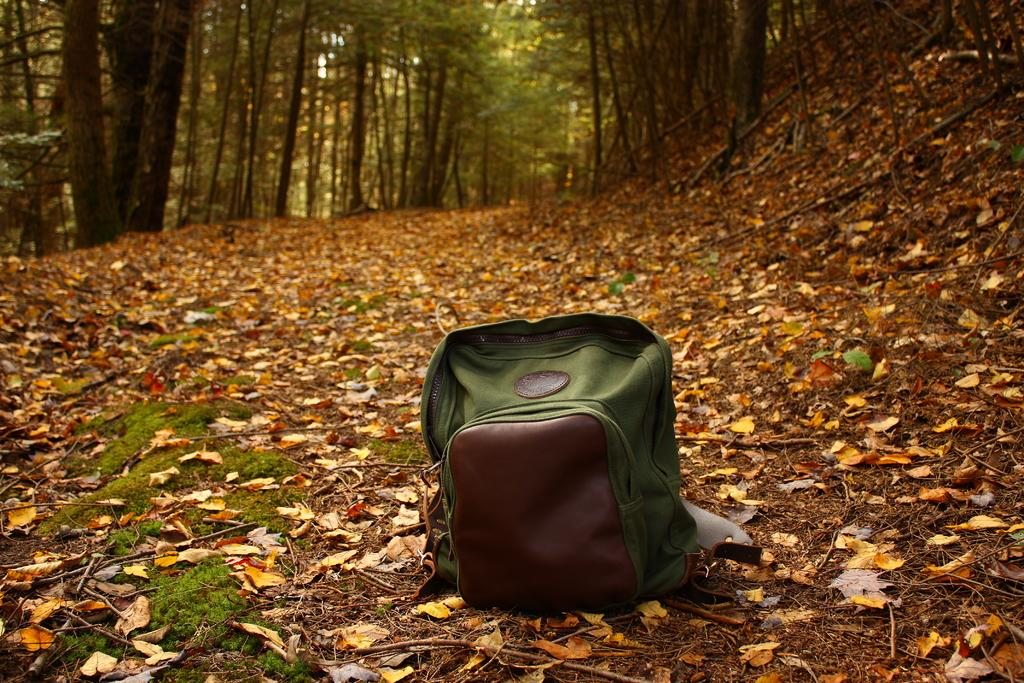Where is the setting of the image? The image is set in an outdoor location. What object can be seen on the floor in the image? There is a bag on the floor in the image. What is the color of the bag? The bag is green in color. What can be observed in the background of the image? There are fallen leaves and trees visible in the background. What type of plant is performing on the stage in the image? There is no stage or plant performing in the image; it is set outdoors with a green bag on the floor and trees in the background. 